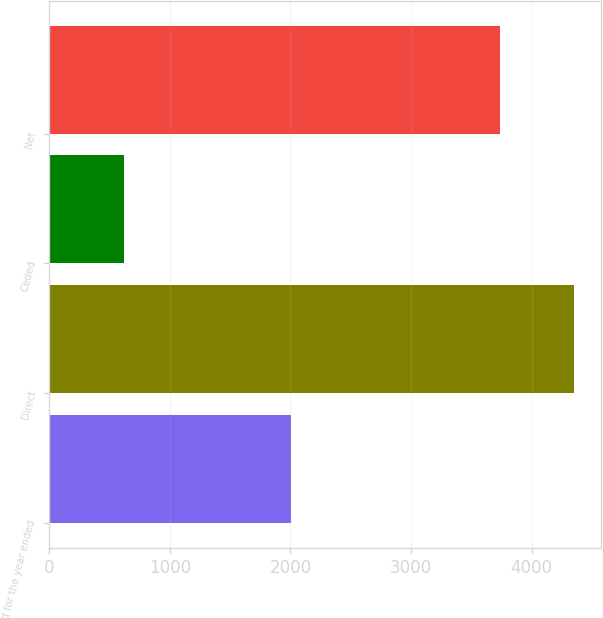Convert chart. <chart><loc_0><loc_0><loc_500><loc_500><bar_chart><fcel>(at and for the year ended<fcel>Direct<fcel>Ceded<fcel>Net<nl><fcel>2008<fcel>4353<fcel>619<fcel>3734<nl></chart> 